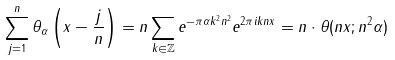<formula> <loc_0><loc_0><loc_500><loc_500>\sum _ { j = 1 } ^ { n } \theta _ { \alpha } \left ( x - \frac { j } { n } \right ) = n \sum _ { k \in \mathbb { Z } } e ^ { - \pi \alpha k ^ { 2 } n ^ { 2 } } e ^ { 2 \pi i k n x } = n \cdot \theta ( n x ; n ^ { 2 } \alpha )</formula> 